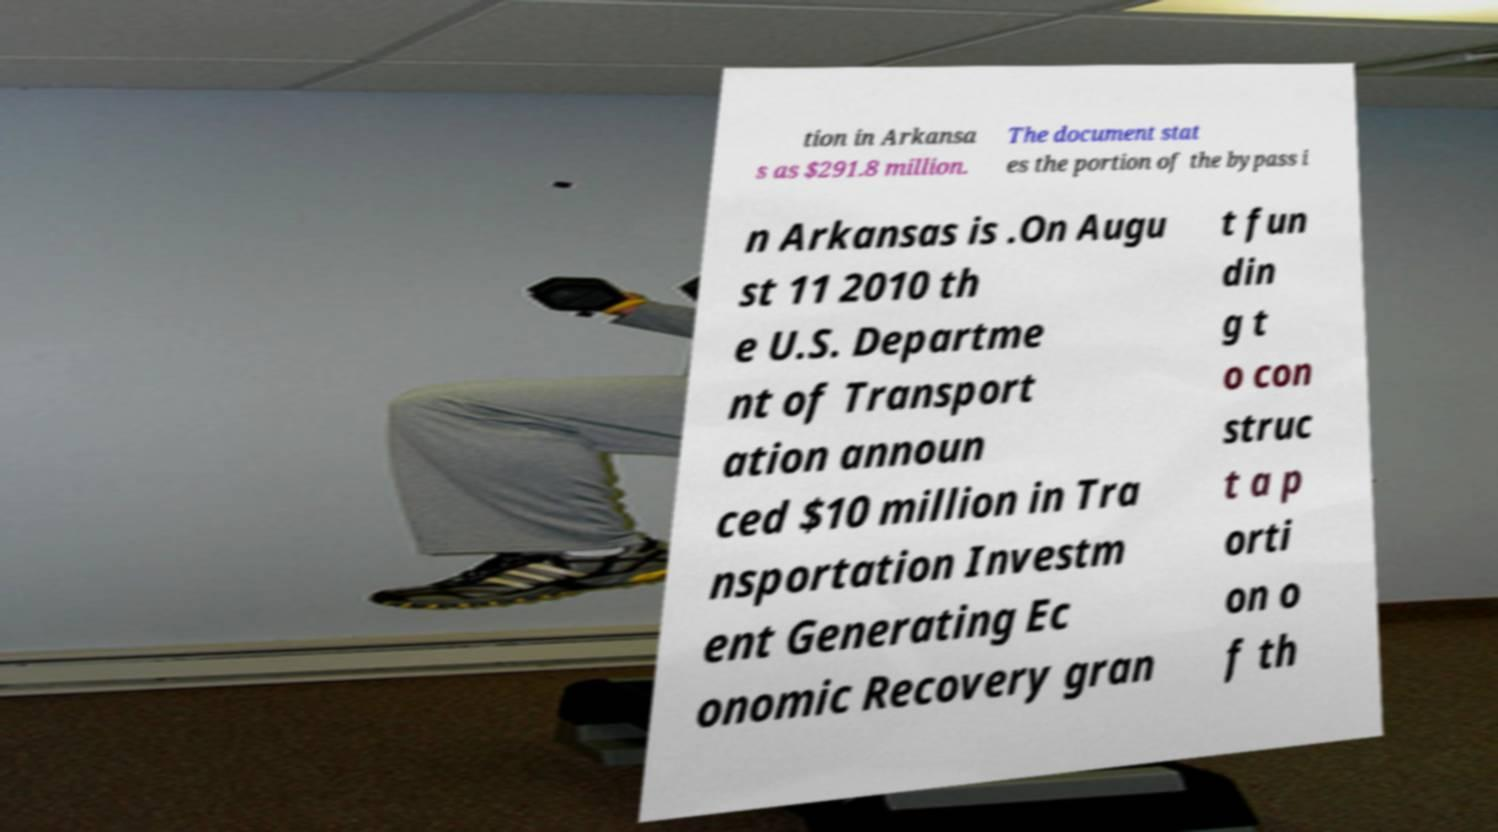Can you read and provide the text displayed in the image?This photo seems to have some interesting text. Can you extract and type it out for me? tion in Arkansa s as $291.8 million. The document stat es the portion of the bypass i n Arkansas is .On Augu st 11 2010 th e U.S. Departme nt of Transport ation announ ced $10 million in Tra nsportation Investm ent Generating Ec onomic Recovery gran t fun din g t o con struc t a p orti on o f th 